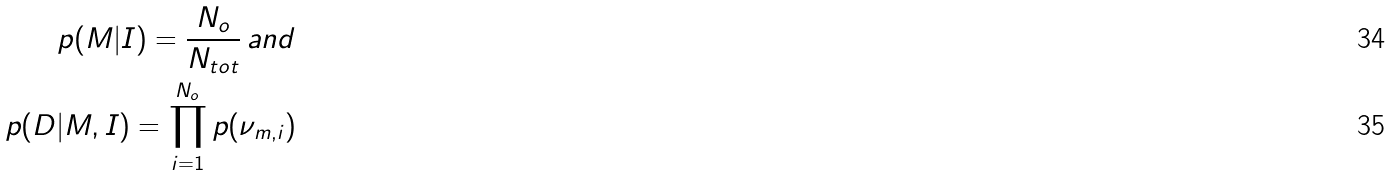<formula> <loc_0><loc_0><loc_500><loc_500>p ( M | I ) = \frac { N _ { o } } { N _ { t o t } } \, a n d \\ p ( D | M , I ) = \prod _ { i = 1 } ^ { N _ { o } } p ( \nu _ { m , i } )</formula> 